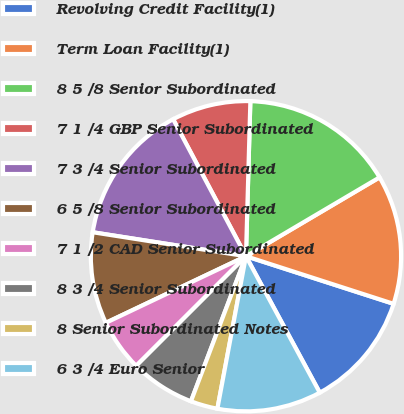Convert chart to OTSL. <chart><loc_0><loc_0><loc_500><loc_500><pie_chart><fcel>Revolving Credit Facility(1)<fcel>Term Loan Facility(1)<fcel>8 5 /8 Senior Subordinated<fcel>7 1 /4 GBP Senior Subordinated<fcel>7 3 /4 Senior Subordinated<fcel>6 5 /8 Senior Subordinated<fcel>7 1 /2 CAD Senior Subordinated<fcel>8 3 /4 Senior Subordinated<fcel>8 Senior Subordinated Notes<fcel>6 3 /4 Euro Senior<nl><fcel>12.14%<fcel>13.45%<fcel>16.06%<fcel>8.23%<fcel>14.75%<fcel>9.53%<fcel>5.43%<fcel>6.74%<fcel>2.82%<fcel>10.84%<nl></chart> 